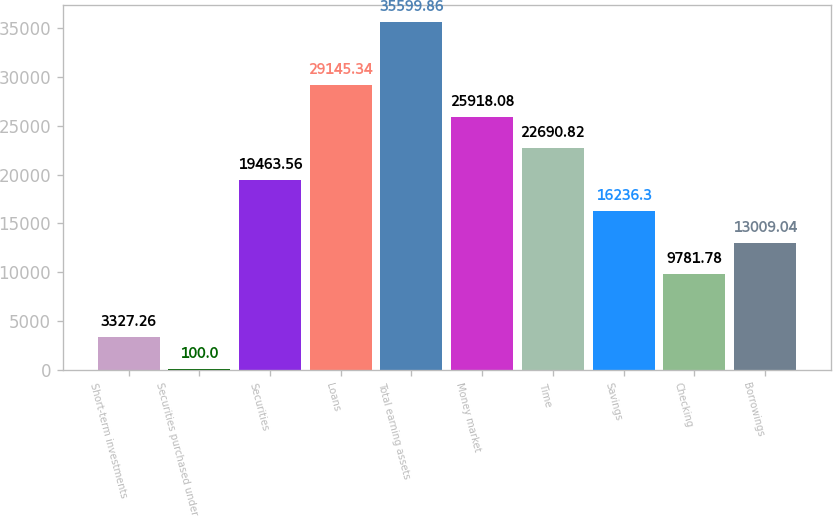Convert chart. <chart><loc_0><loc_0><loc_500><loc_500><bar_chart><fcel>Short-term investments<fcel>Securities purchased under<fcel>Securities<fcel>Loans<fcel>Total earning assets<fcel>Money market<fcel>Time<fcel>Savings<fcel>Checking<fcel>Borrowings<nl><fcel>3327.26<fcel>100<fcel>19463.6<fcel>29145.3<fcel>35599.9<fcel>25918.1<fcel>22690.8<fcel>16236.3<fcel>9781.78<fcel>13009<nl></chart> 